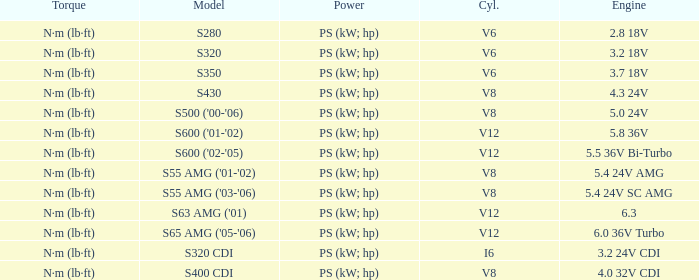Which Torque has a Model of s63 amg ('01)? N·m (lb·ft). 